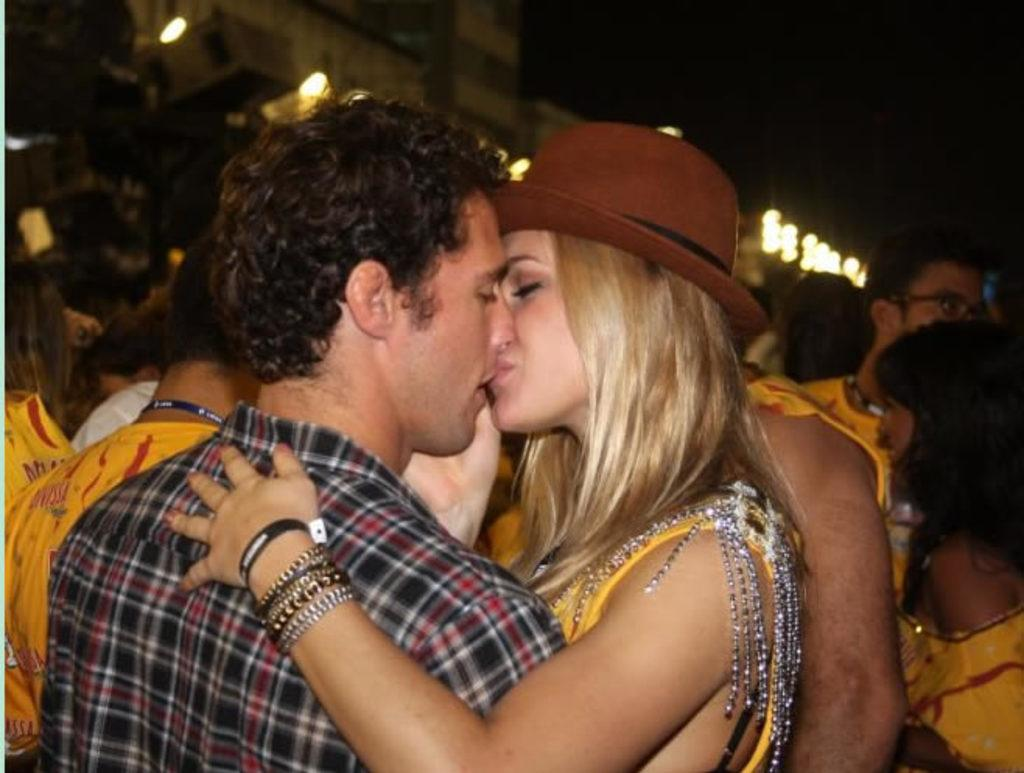Who are the two people in the foreground of the image? There is a man and a woman in the foreground of the image. What are the man and woman doing in the image? The man and woman are kissing each other. What can be seen in the background of the image? There are people, buildings, lights, and a dark sky visible in the background of the image. What is the fifth element in the plot of the image? There is no plot in the image, as it is a photograph of a man and a woman kissing each other. What type of copper material can be seen in the image? There is no copper material present in the image. 